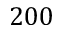Convert formula to latex. <formula><loc_0><loc_0><loc_500><loc_500>2 0 0</formula> 